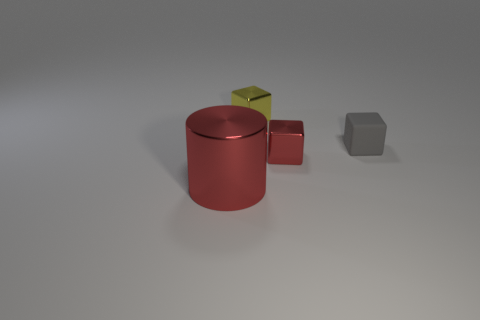Subtract all red blocks. How many blocks are left? 2 Subtract all gray cubes. How many cubes are left? 2 Add 1 red matte balls. How many objects exist? 5 Subtract all blocks. How many objects are left? 1 Subtract 0 brown blocks. How many objects are left? 4 Subtract 3 blocks. How many blocks are left? 0 Subtract all green cubes. Subtract all gray balls. How many cubes are left? 3 Subtract all small purple things. Subtract all tiny yellow objects. How many objects are left? 3 Add 1 small red metallic things. How many small red metallic things are left? 2 Add 1 gray matte things. How many gray matte things exist? 2 